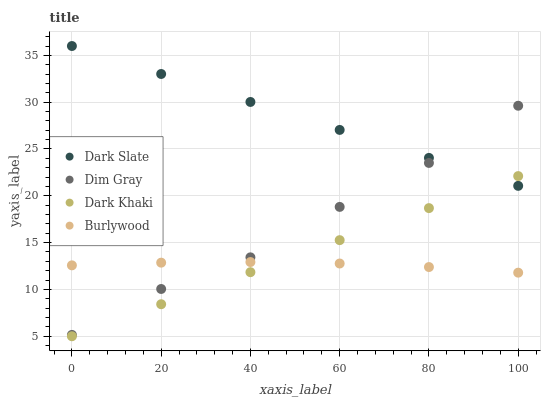Does Burlywood have the minimum area under the curve?
Answer yes or no. Yes. Does Dark Slate have the maximum area under the curve?
Answer yes or no. Yes. Does Dim Gray have the minimum area under the curve?
Answer yes or no. No. Does Dim Gray have the maximum area under the curve?
Answer yes or no. No. Is Dark Khaki the smoothest?
Answer yes or no. Yes. Is Dim Gray the roughest?
Answer yes or no. Yes. Is Dark Slate the smoothest?
Answer yes or no. No. Is Dark Slate the roughest?
Answer yes or no. No. Does Dark Khaki have the lowest value?
Answer yes or no. Yes. Does Dim Gray have the lowest value?
Answer yes or no. No. Does Dark Slate have the highest value?
Answer yes or no. Yes. Does Dim Gray have the highest value?
Answer yes or no. No. Is Dark Khaki less than Dim Gray?
Answer yes or no. Yes. Is Dark Slate greater than Burlywood?
Answer yes or no. Yes. Does Dim Gray intersect Dark Slate?
Answer yes or no. Yes. Is Dim Gray less than Dark Slate?
Answer yes or no. No. Is Dim Gray greater than Dark Slate?
Answer yes or no. No. Does Dark Khaki intersect Dim Gray?
Answer yes or no. No. 